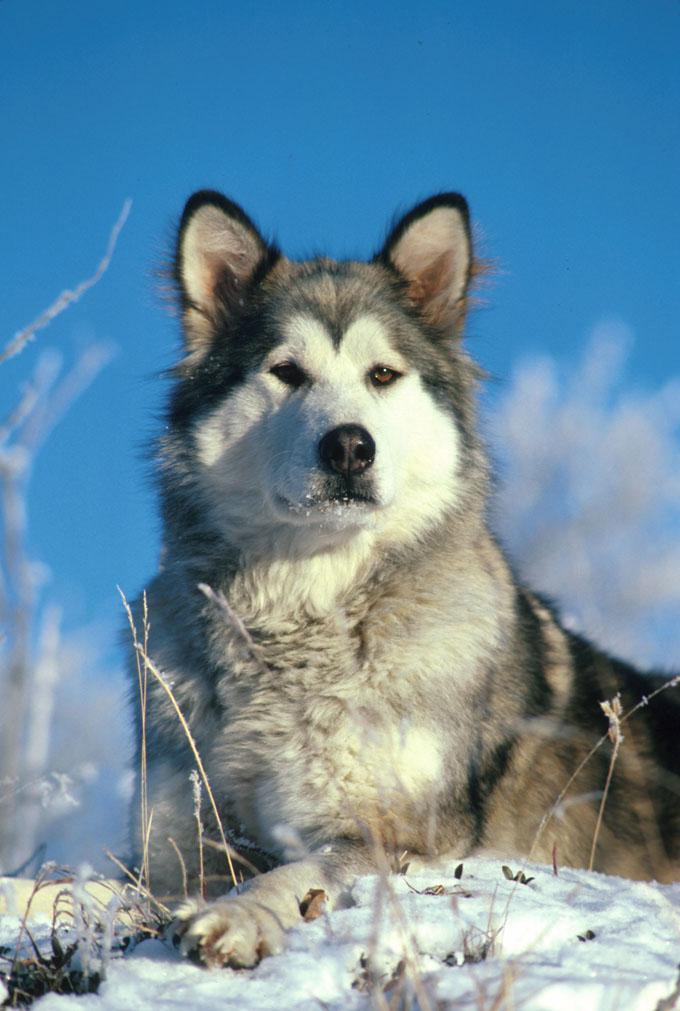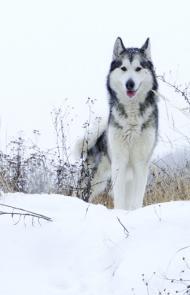The first image is the image on the left, the second image is the image on the right. Examine the images to the left and right. Is the description "The right image contains one dog standing on green grass." accurate? Answer yes or no. No. The first image is the image on the left, the second image is the image on the right. Evaluate the accuracy of this statement regarding the images: "All dogs are standing with bodies in profile, at least one with its tail curled inward toward its back, and the dogs in the left and right images gaze in the same direction.". Is it true? Answer yes or no. No. 